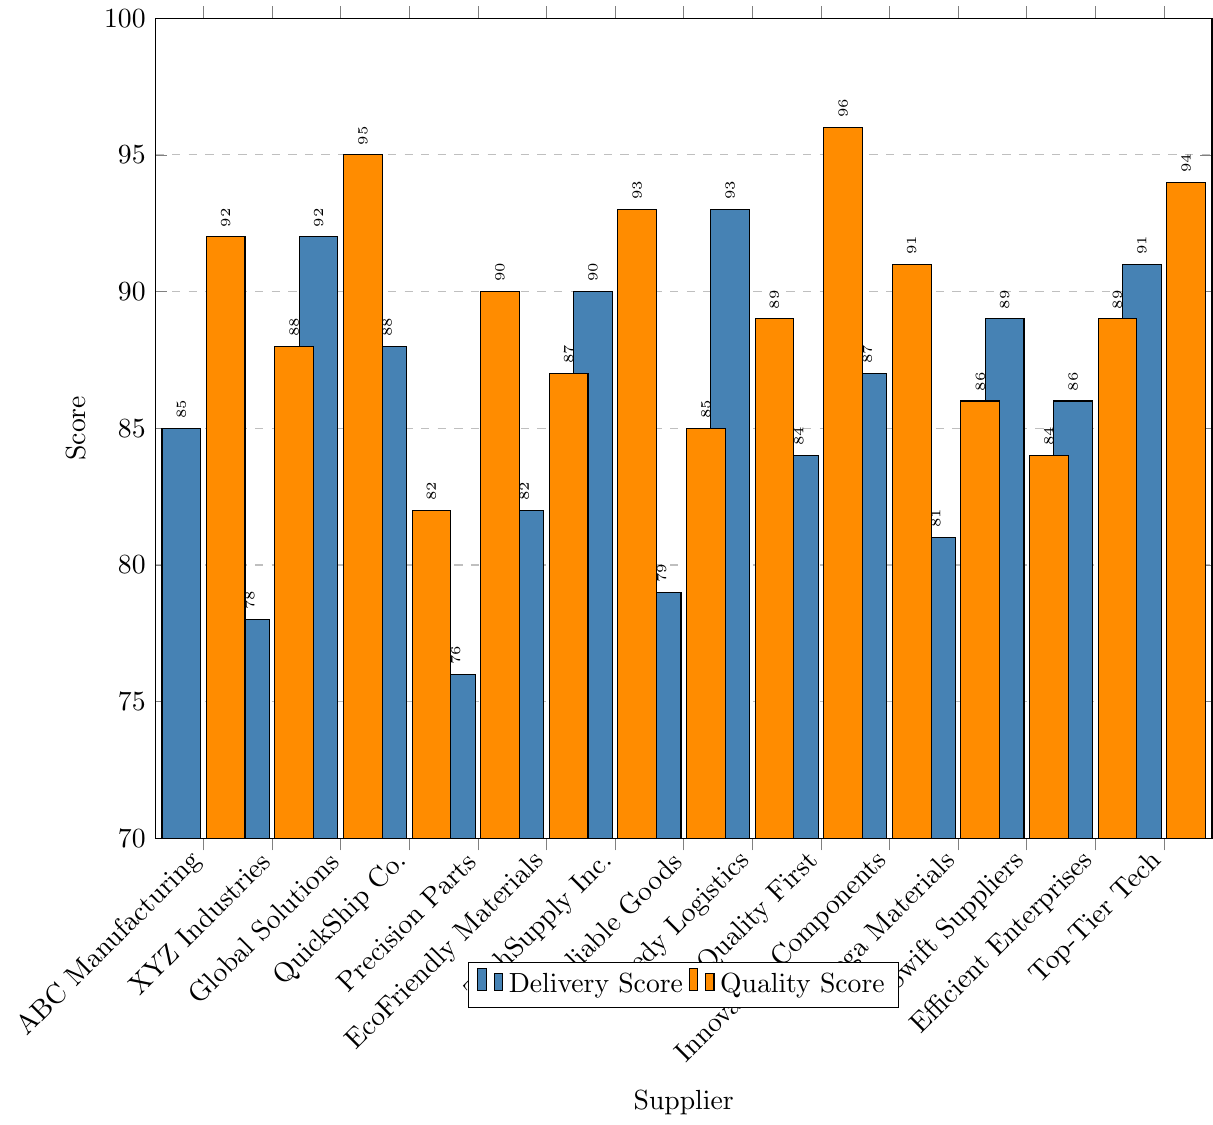What's the highest delivery score among all suppliers? The highest delivery score can be identified by looking at the highest bar in the delivery score color. The tallest bar for delivery is at Speedy Logistics, which has a score of 93.
Answer: 93 Which supplier has the lowest quality score? The lowest quality score can be identified by looking at the shortest bar in the quality score color. The shortest bar for quality is at Swift Suppliers, which has a score of 84.
Answer: Swift Suppliers What’s the average quality score of all suppliers? To calculate the average quality score, sum all the quality scores and divide by the number of suppliers. The scores are 92, 88, 95, 82, 90, 87, 93, 85, 89, 96, 91, 86, 84, 89, 94. Total sum = 1241. Number of suppliers = 15. Average = 1241 / 15 ≈ 82.73.
Answer: 87.93 Which supplier has a higher delivery score, ABC Manufacturing or XYZ Industries? Compare the heights of the delivery score bars for ABC Manufacturing and XYZ Industries. ABC Manufacturing has a score of 85, while XYZ Industries has 78.
Answer: ABC Manufacturing How many suppliers have a quality score above 90? Identify the suppliers whose quality score bars extend above the 90 mark. These suppliers are ABC Manufacturing (92), Global Solutions (95), TechSupply Inc. (93), Quality First (96), Innovative Components (91), and Top-Tier Tech (94). There are 6 suppliers.
Answer: 6 Which two suppliers have the smallest difference between their delivery and quality scores? Calculate the difference between delivery and quality scores for all suppliers. The two suppliers with the smallest differences are Global Solutions (92 vs 95 = 3) and Top-Tier Tech (91 vs 94 = 3).
Answer: Global Solutions and Top-Tier Tech What's the average delivery score of the top 5 suppliers by quality score? First, identify the top 5 suppliers by quality score: Quality First (96), Global Solutions (95), Top-Tier Tech (94), TechSupply Inc. (93), and Innovative Components (91). Their delivery scores are 84, 92, 91, 90, and 87 respectively. Sum of these scores = 444. Average = 444 / 5 = 88.8.
Answer: 88.8 Which supplier shows a larger discrepancy between delivery and quality score, QuickShip Co. or Precision Parts? Calculate the difference for both suppliers: QuickShip Co. has scores 88 (delivery) and 82 (quality), difference = 6. Precision Parts has scores 76 (delivery) and 90 (quality), difference = 14.
Answer: Precision Parts Which supplier has a quality score equal to or higher than its delivery score? List suppliers where the quality score bar is as high or higher than the delivery score bar: ABC Manufacturing, Precision Parts, EcoFriendly Materials, Reliable Goods, Quality First, Innovative Components, Mega Materials, Top-Tier Tech.
Answer: 8 suppliers How many suppliers have a delivery score between 80 and 90? Identify suppliers whose delivery score bars fall between the 80 and 90 marks: ABC Manufacturing (85), EcoFriendly Materials (82), QuickShip Co. (88), Reliable Goods (79), Swift Suppliers (89), Efficient Enterprises (86), Mega Materials (81), Innovative Components (87). There are 8 suppliers.
Answer: 8 